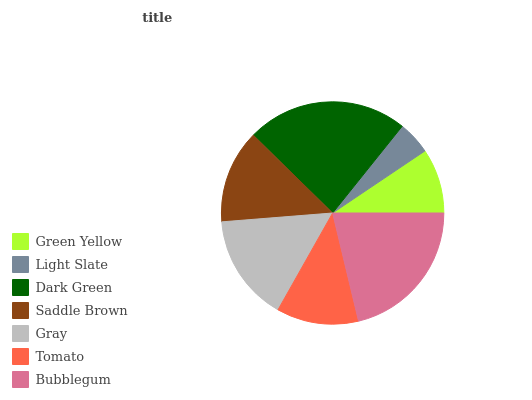Is Light Slate the minimum?
Answer yes or no. Yes. Is Dark Green the maximum?
Answer yes or no. Yes. Is Dark Green the minimum?
Answer yes or no. No. Is Light Slate the maximum?
Answer yes or no. No. Is Dark Green greater than Light Slate?
Answer yes or no. Yes. Is Light Slate less than Dark Green?
Answer yes or no. Yes. Is Light Slate greater than Dark Green?
Answer yes or no. No. Is Dark Green less than Light Slate?
Answer yes or no. No. Is Saddle Brown the high median?
Answer yes or no. Yes. Is Saddle Brown the low median?
Answer yes or no. Yes. Is Green Yellow the high median?
Answer yes or no. No. Is Dark Green the low median?
Answer yes or no. No. 